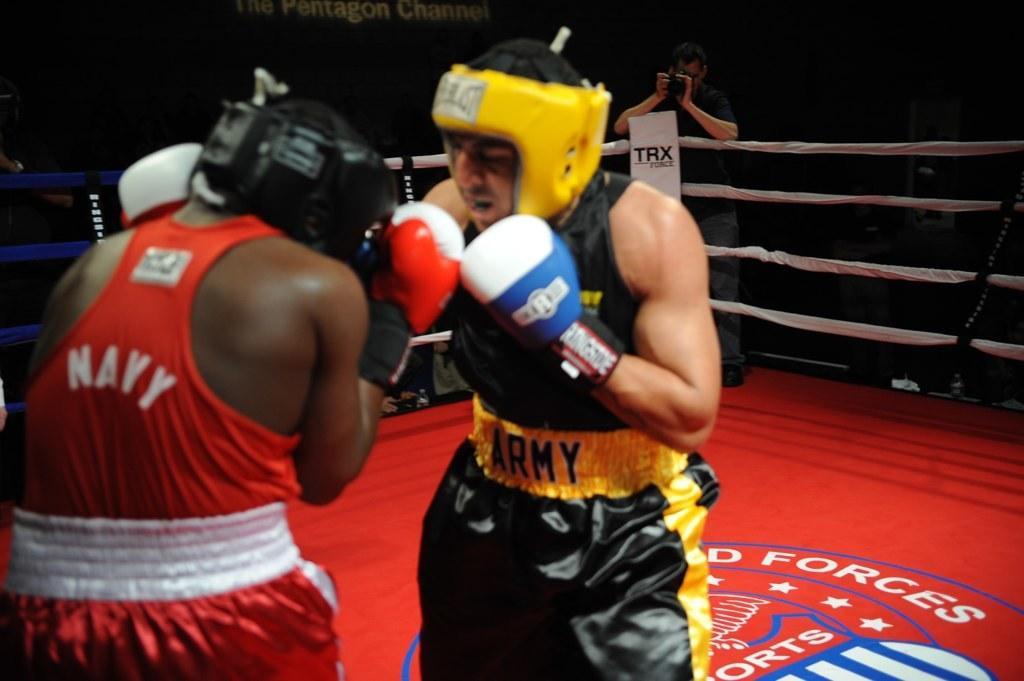How would you summarize this image in a sentence or two? In the picture we can see the wrestling of two people and they are wearing a wrestling dress and boxing gloves and helmets and standing on the wrestling floor and around it we can see a railing with ropes and one person standing near it and capturing them with the camera holding it. 